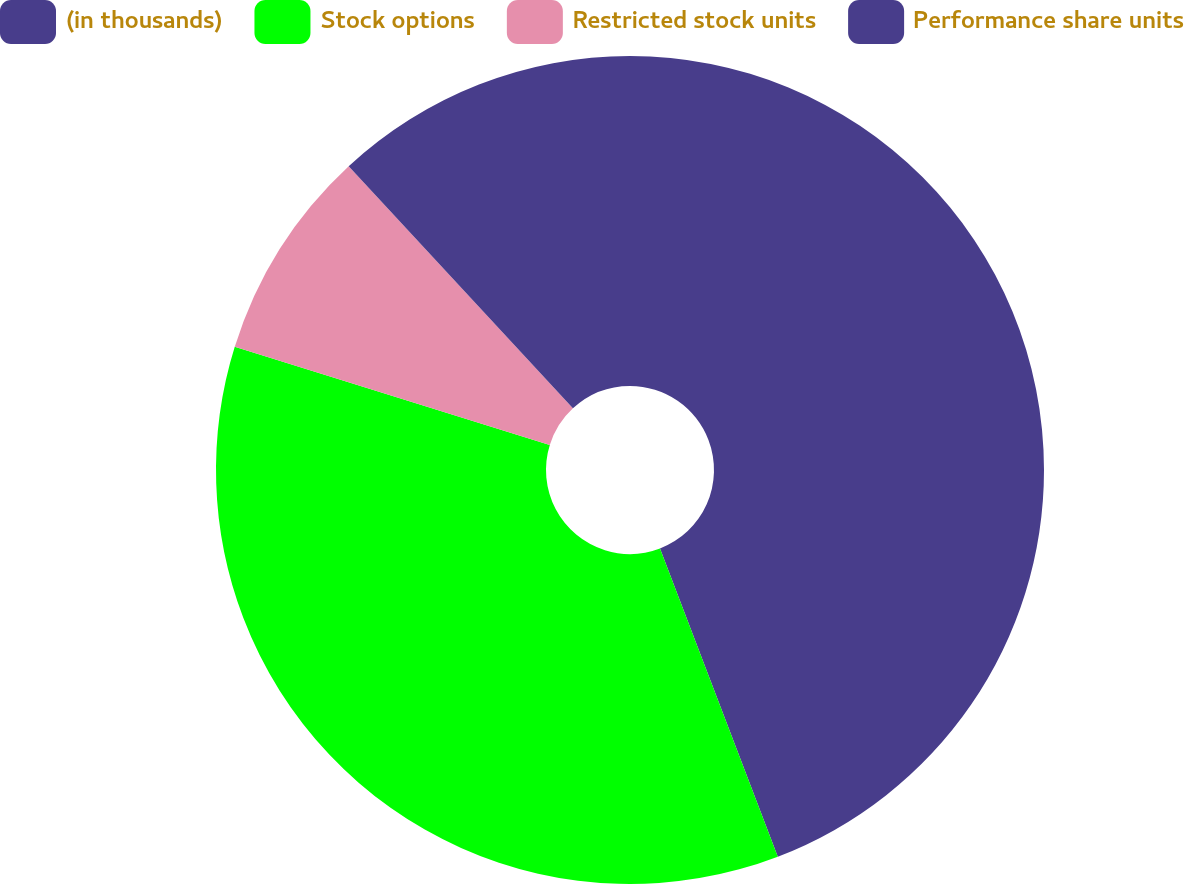<chart> <loc_0><loc_0><loc_500><loc_500><pie_chart><fcel>(in thousands)<fcel>Stock options<fcel>Restricted stock units<fcel>Performance share units<nl><fcel>44.19%<fcel>35.62%<fcel>8.3%<fcel>11.89%<nl></chart> 